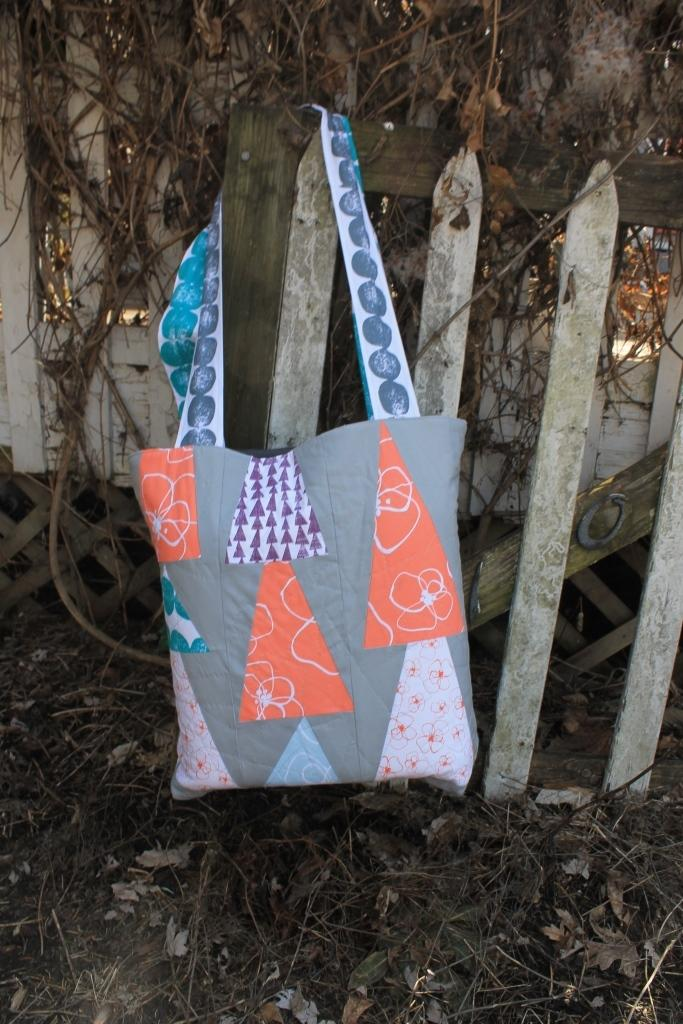What object is present in the image that is typically used for carrying items? There is a bag in the image. How is the bag positioned in the image? The bag is hanging on a fence. What type of scientific experiment is being conducted with the bag in the image? There is no scientific experiment being conducted with the bag in the image. How many cakes are visible inside the bag in the image? There are no cakes visible inside the bag in the image. 